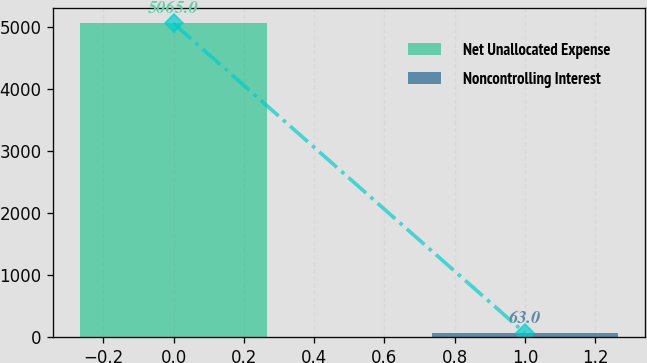Convert chart to OTSL. <chart><loc_0><loc_0><loc_500><loc_500><bar_chart><fcel>Net Unallocated Expense<fcel>Noncontrolling Interest<nl><fcel>5065<fcel>63<nl></chart> 